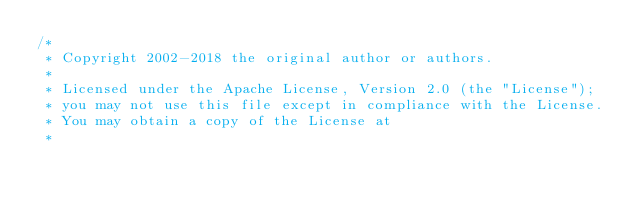Convert code to text. <code><loc_0><loc_0><loc_500><loc_500><_Kotlin_>/*
 * Copyright 2002-2018 the original author or authors.
 *
 * Licensed under the Apache License, Version 2.0 (the "License");
 * you may not use this file except in compliance with the License.
 * You may obtain a copy of the License at
 *</code> 